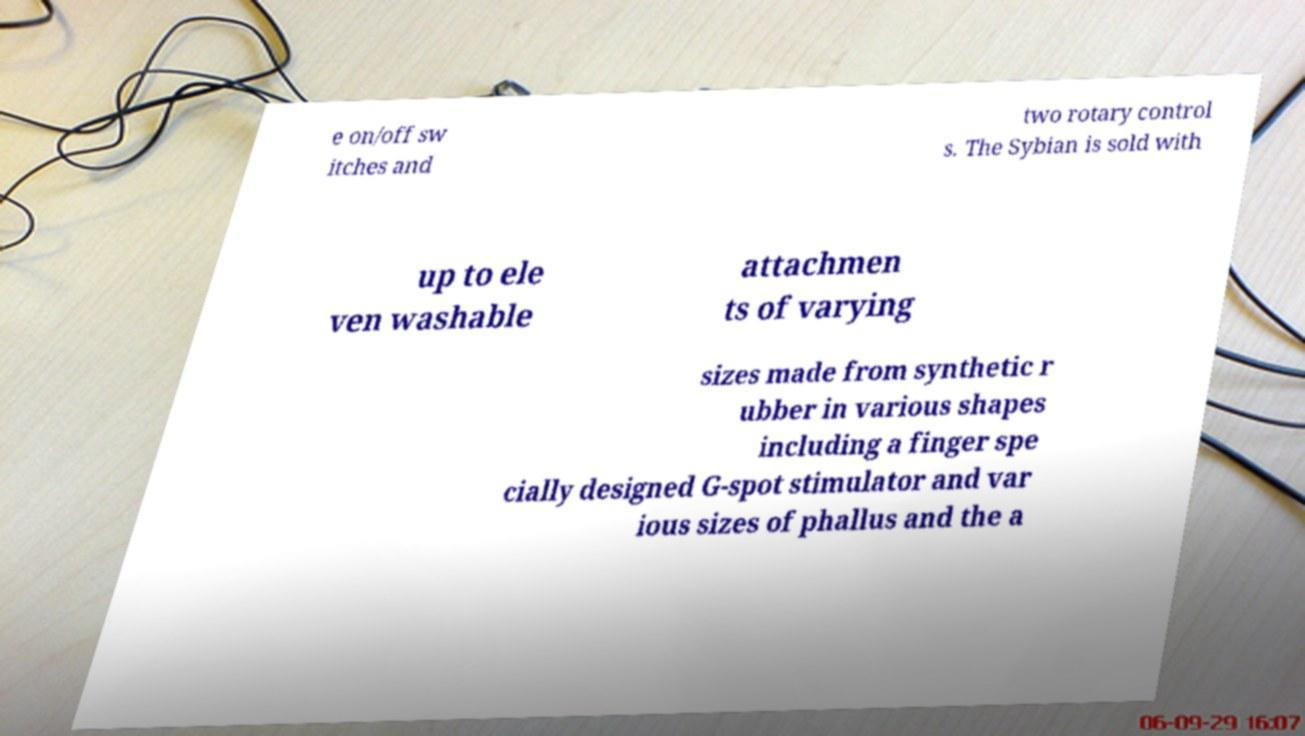Could you assist in decoding the text presented in this image and type it out clearly? e on/off sw itches and two rotary control s. The Sybian is sold with up to ele ven washable attachmen ts of varying sizes made from synthetic r ubber in various shapes including a finger spe cially designed G-spot stimulator and var ious sizes of phallus and the a 